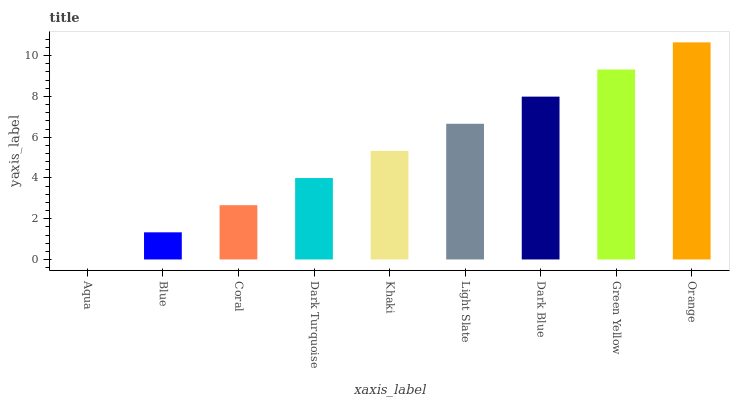Is Aqua the minimum?
Answer yes or no. Yes. Is Orange the maximum?
Answer yes or no. Yes. Is Blue the minimum?
Answer yes or no. No. Is Blue the maximum?
Answer yes or no. No. Is Blue greater than Aqua?
Answer yes or no. Yes. Is Aqua less than Blue?
Answer yes or no. Yes. Is Aqua greater than Blue?
Answer yes or no. No. Is Blue less than Aqua?
Answer yes or no. No. Is Khaki the high median?
Answer yes or no. Yes. Is Khaki the low median?
Answer yes or no. Yes. Is Light Slate the high median?
Answer yes or no. No. Is Orange the low median?
Answer yes or no. No. 